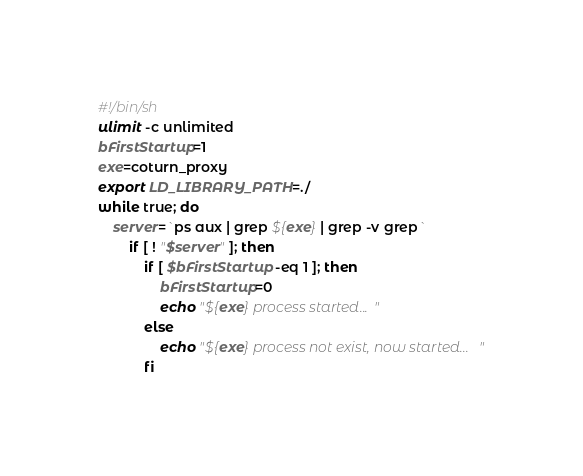Convert code to text. <code><loc_0><loc_0><loc_500><loc_500><_Bash_>#!/bin/sh
ulimit -c unlimited
bFirstStartup=1
exe=coturn_proxy
export LD_LIBRARY_PATH=./
while true; do
	server=`ps aux | grep ${exe} | grep -v grep`
		if [ ! "$server" ]; then
			if [ $bFirstStartup -eq 1 ]; then
				bFirstStartup=0
				echo "${exe} process started..."
			else
				echo "${exe} process not exist, now started..."
			fi</code> 